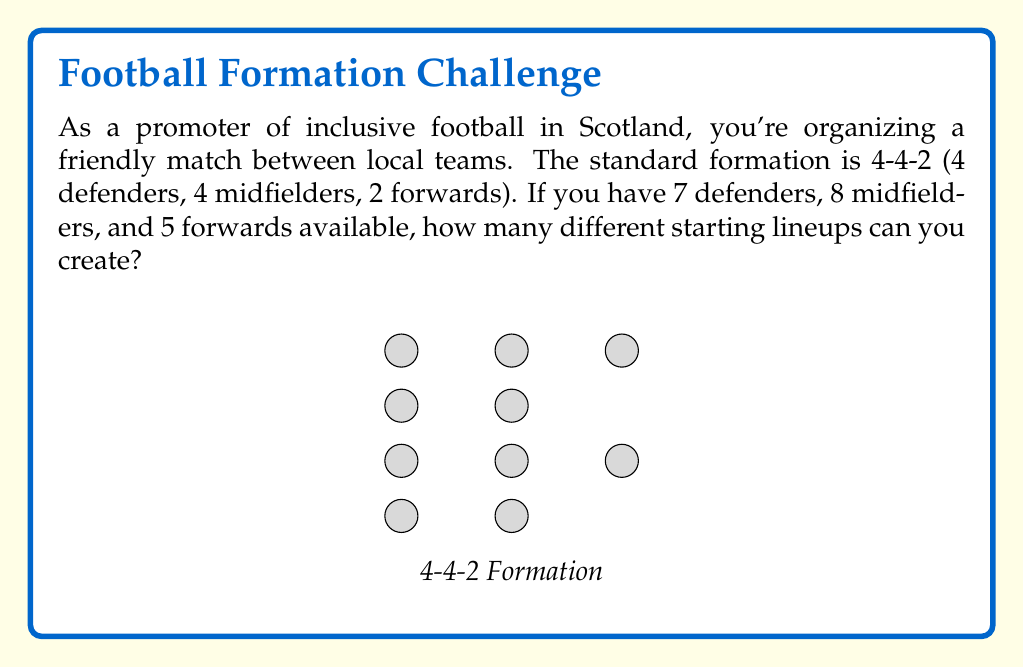Provide a solution to this math problem. Let's break this down step-by-step:

1) We need to choose:
   - 4 out of 7 defenders
   - 4 out of 8 midfielders
   - 2 out of 5 forwards

2) For each position, we can use the combination formula:
   $${n \choose k} = \frac{n!}{k!(n-k)!}$$

3) For defenders: ${7 \choose 4} = \frac{7!}{4!(7-4)!} = \frac{7!}{4!3!} = 35$

4) For midfielders: ${8 \choose 4} = \frac{8!}{4!(8-4)!} = \frac{8!}{4!4!} = 70$

5) For forwards: ${5 \choose 2} = \frac{5!}{2!(5-2)!} = \frac{5!}{2!3!} = 10$

6) By the multiplication principle, the total number of possible lineups is:
   $35 \times 70 \times 10 = 24,500$

Therefore, there are 24,500 different possible starting lineups.
Answer: 24,500 